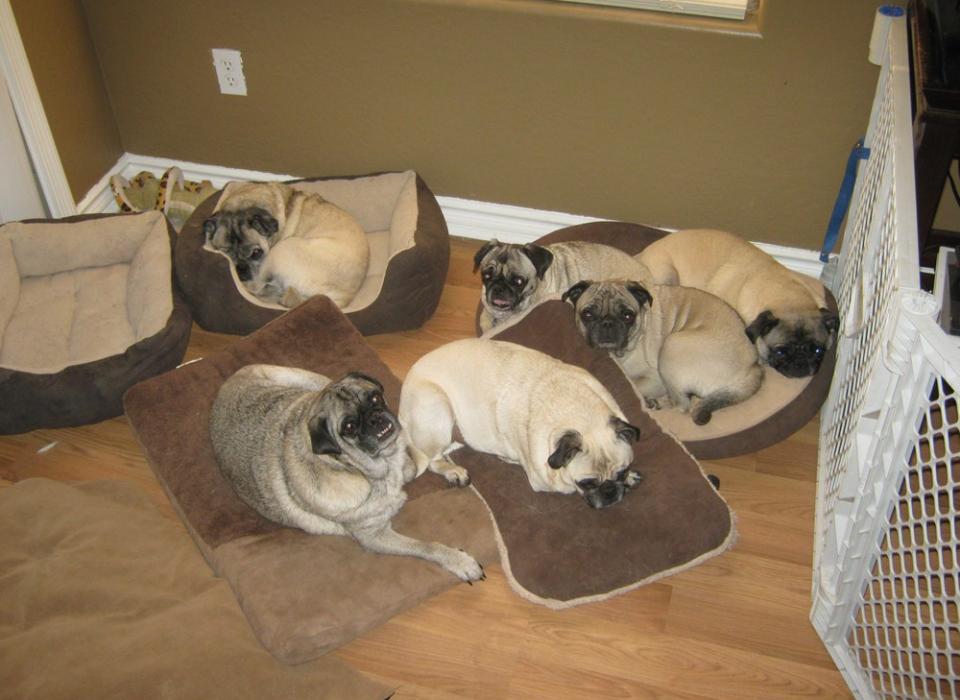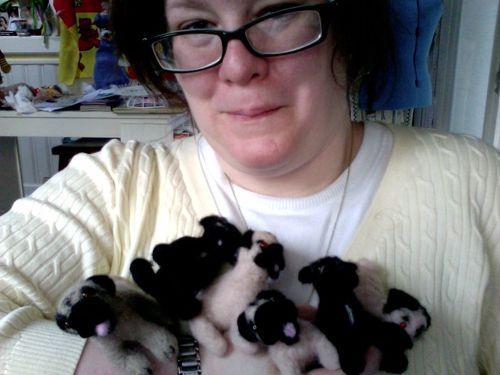The first image is the image on the left, the second image is the image on the right. Assess this claim about the two images: "In at least one image, at least one pug is wearing clothes.". Correct or not? Answer yes or no. No. The first image is the image on the left, the second image is the image on the right. For the images shown, is this caption "At least one of the images contains only a single pug." true? Answer yes or no. No. 